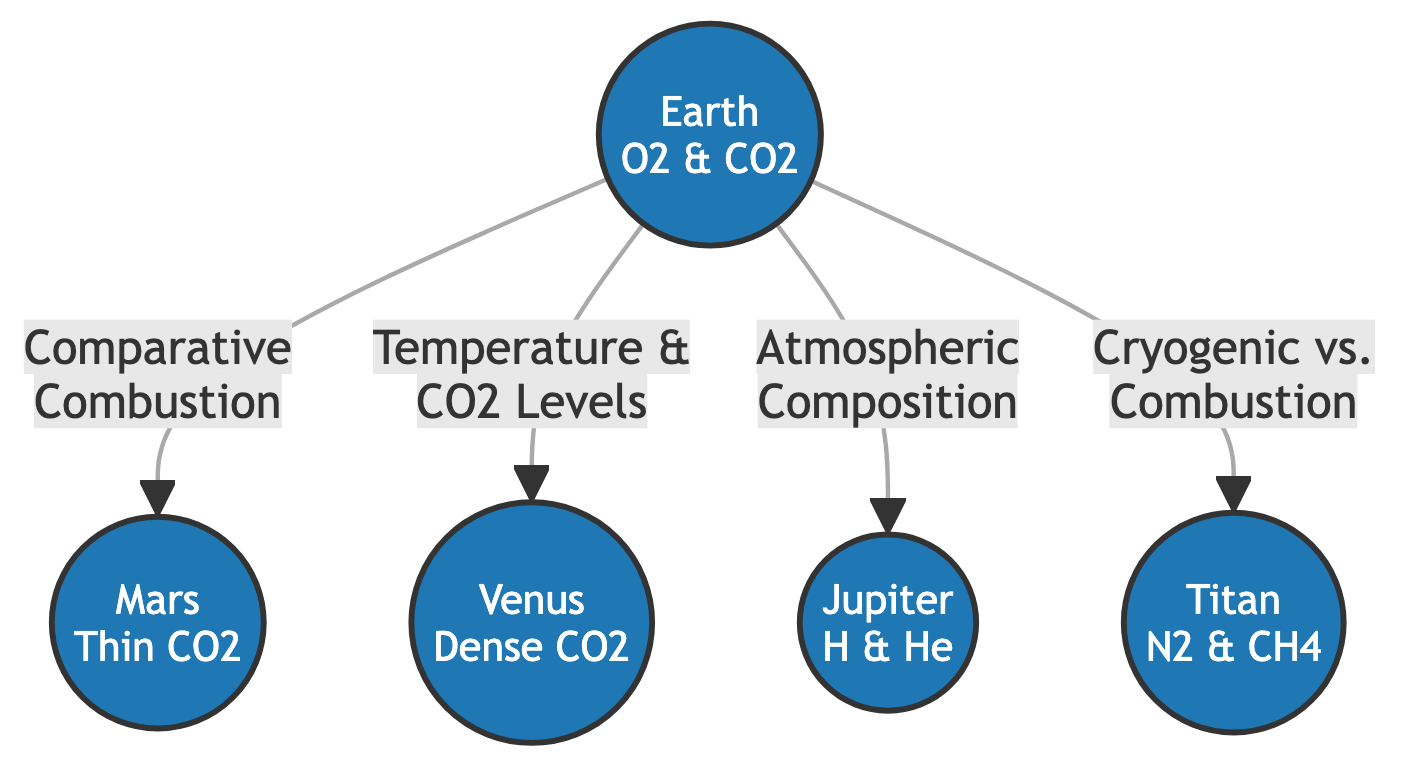What's the atmospheric composition of Earth? The diagram indicates that Earth has O2 and CO2 as its atmospheric composition.
Answer: O2 & CO2 How many planets are depicted in this diagram? Counting the nodes in the diagram reveals that there are five planets shown: Earth, Mars, Venus, Jupiter, and Titan.
Answer: 5 Which planet has a dense atmosphere of CO2? According to the diagram, Venus is identified as having a dense atmosphere of CO2.
Answer: Venus What is the relationship between Earth and Mars in the diagram? The diagram shows an arrow from Earth to Mars labeled "Comparative Combustion," indicating a direct relationship regarding combustion properties.
Answer: Comparative Combustion What type of gases compose the atmosphere of Titan? The diagram specifies that Titan's atmosphere is made up of N2 and CH4.
Answer: N2 & CH4 How does Earth's atmosphere compare to Jupiter's? The diagram illustrates that Earth's atmospheric composition is compared to Jupiter's, which consists of H and He, as indicated by the "Atmospheric Composition" label.
Answer: H & He What flow relationship exists between Earth and Venus concerning temperature? The arrow from Earth to Venus is labeled "Temperature & CO2 Levels," suggesting a flow of information related to these aspects.
Answer: Temperature & CO2 Levels Which planet is connected to Earth by a comparison of cryogenic versus combustion? The diagram links Earth to Titan through the labeling "Cryogenic vs. Combustion," showing that these two are being compared on this basis.
Answer: Titan What type of atmosphere does Mars have? According to the diagram, Mars is described as having a "Thin CO2" atmosphere.
Answer: Thin CO2 